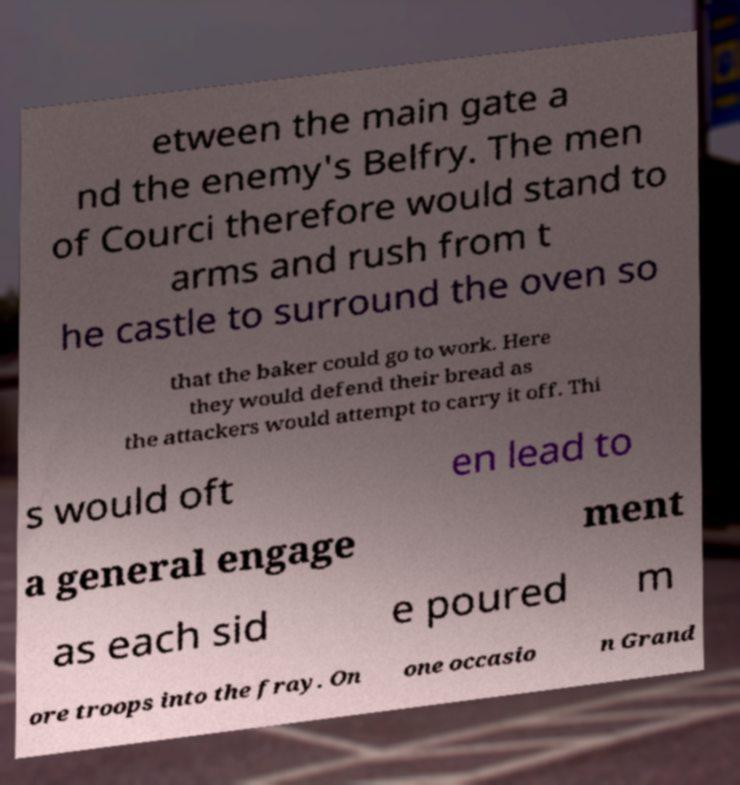For documentation purposes, I need the text within this image transcribed. Could you provide that? etween the main gate a nd the enemy's Belfry. The men of Courci therefore would stand to arms and rush from t he castle to surround the oven so that the baker could go to work. Here they would defend their bread as the attackers would attempt to carry it off. Thi s would oft en lead to a general engage ment as each sid e poured m ore troops into the fray. On one occasio n Grand 